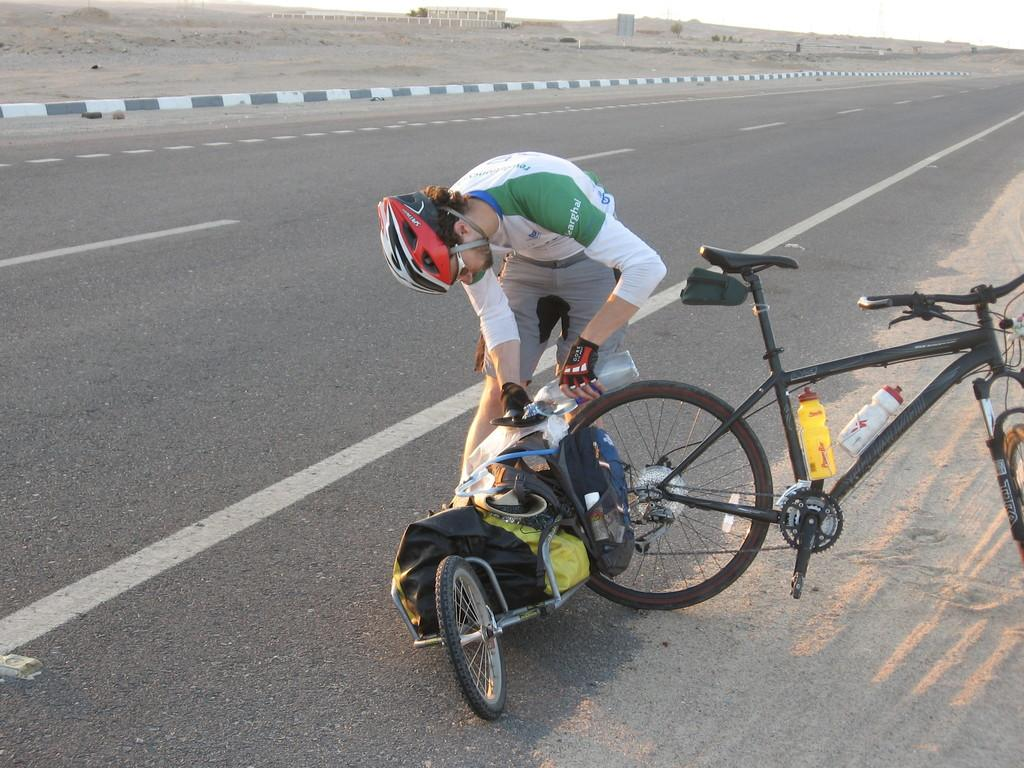Who is present in the image? There is a person in the image. What is the person holding? The person is holding a bottle. What can be seen in the background of the image? There is a bicycle in the image. How is the bicycle positioned in the image? The bicycle is parked beside the road. Are there any cobwebs visible on the person's legs in the image? There is no mention of cobwebs or legs in the provided facts, so we cannot determine if any are present in the image. 